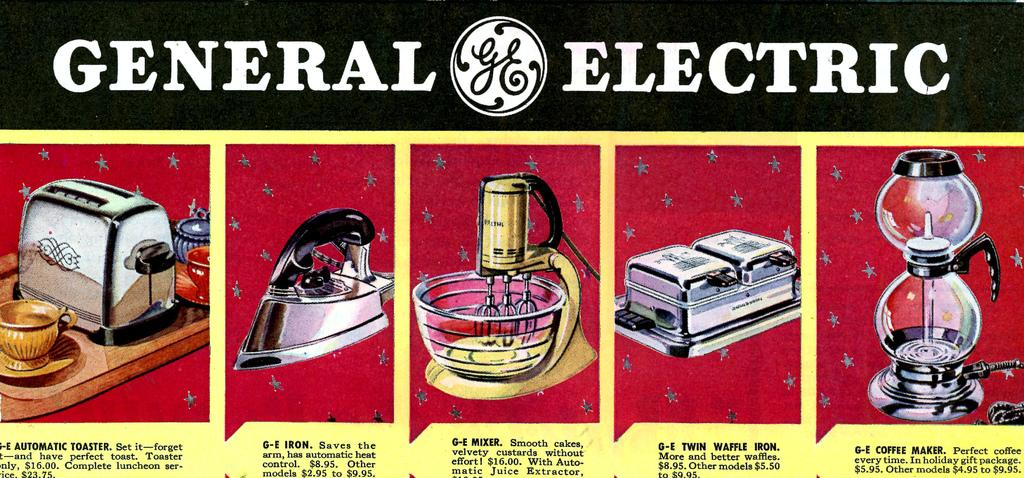Provide a one-sentence caption for the provided image. Genreal elecric ad sign trying to sell kitchen appliances. 